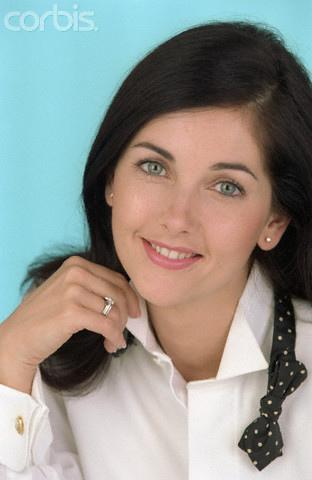Are there any noticeable features or patterns on the woman's bow tie? Yes, the bow tie has white polka dots on it. How would you describe the background behind the woman? The background behind the woman is blue. What accessory is the woman wearing on her hands? The woman is wearing a ring on her finger. What type of shirt is the woman wearing? The woman is wearing a white collared shirt. What is unique about the bow tie in the image? The bow tie is off the woman's shoulder, and it has a polka dot pattern with black and tan colors. Provide a detailed description of the woman's hair. The woman has long, dark brown hair. Describe the woman's appearance in detail. The woman has long, dark brown hair, green eyes, dark eyebrows, and is smiling with white teeth. She is wearing earrings, a ring, and a white collared shirt with buttons. Additionally, she has a bow tie hanging off her shoulder. What is the color of the woman's eyes in the image? The woman has blue and green eyes. Is the woman wearing any earrings? If so, provide a brief description. Yes, the woman is wearing small earrings on her earlobes. 